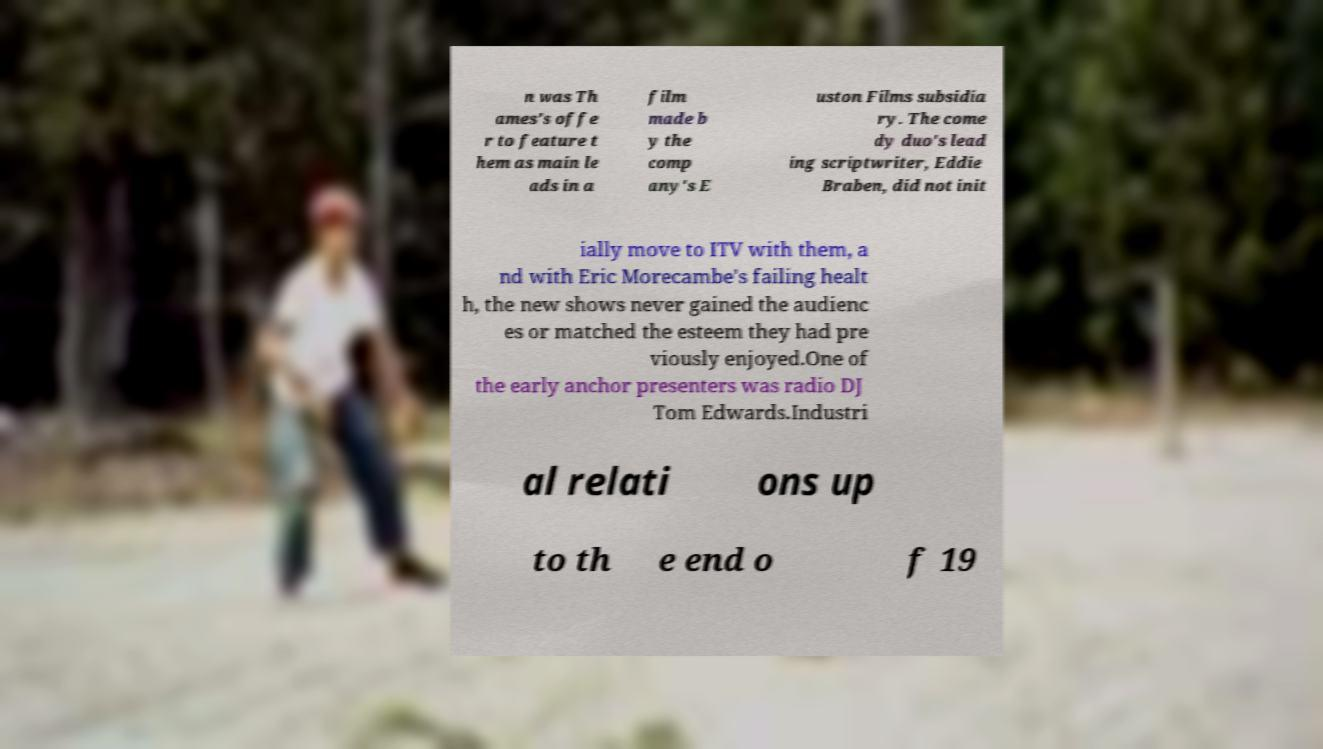Please read and relay the text visible in this image. What does it say? n was Th ames's offe r to feature t hem as main le ads in a film made b y the comp any's E uston Films subsidia ry. The come dy duo's lead ing scriptwriter, Eddie Braben, did not init ially move to ITV with them, a nd with Eric Morecambe's failing healt h, the new shows never gained the audienc es or matched the esteem they had pre viously enjoyed.One of the early anchor presenters was radio DJ Tom Edwards.Industri al relati ons up to th e end o f 19 